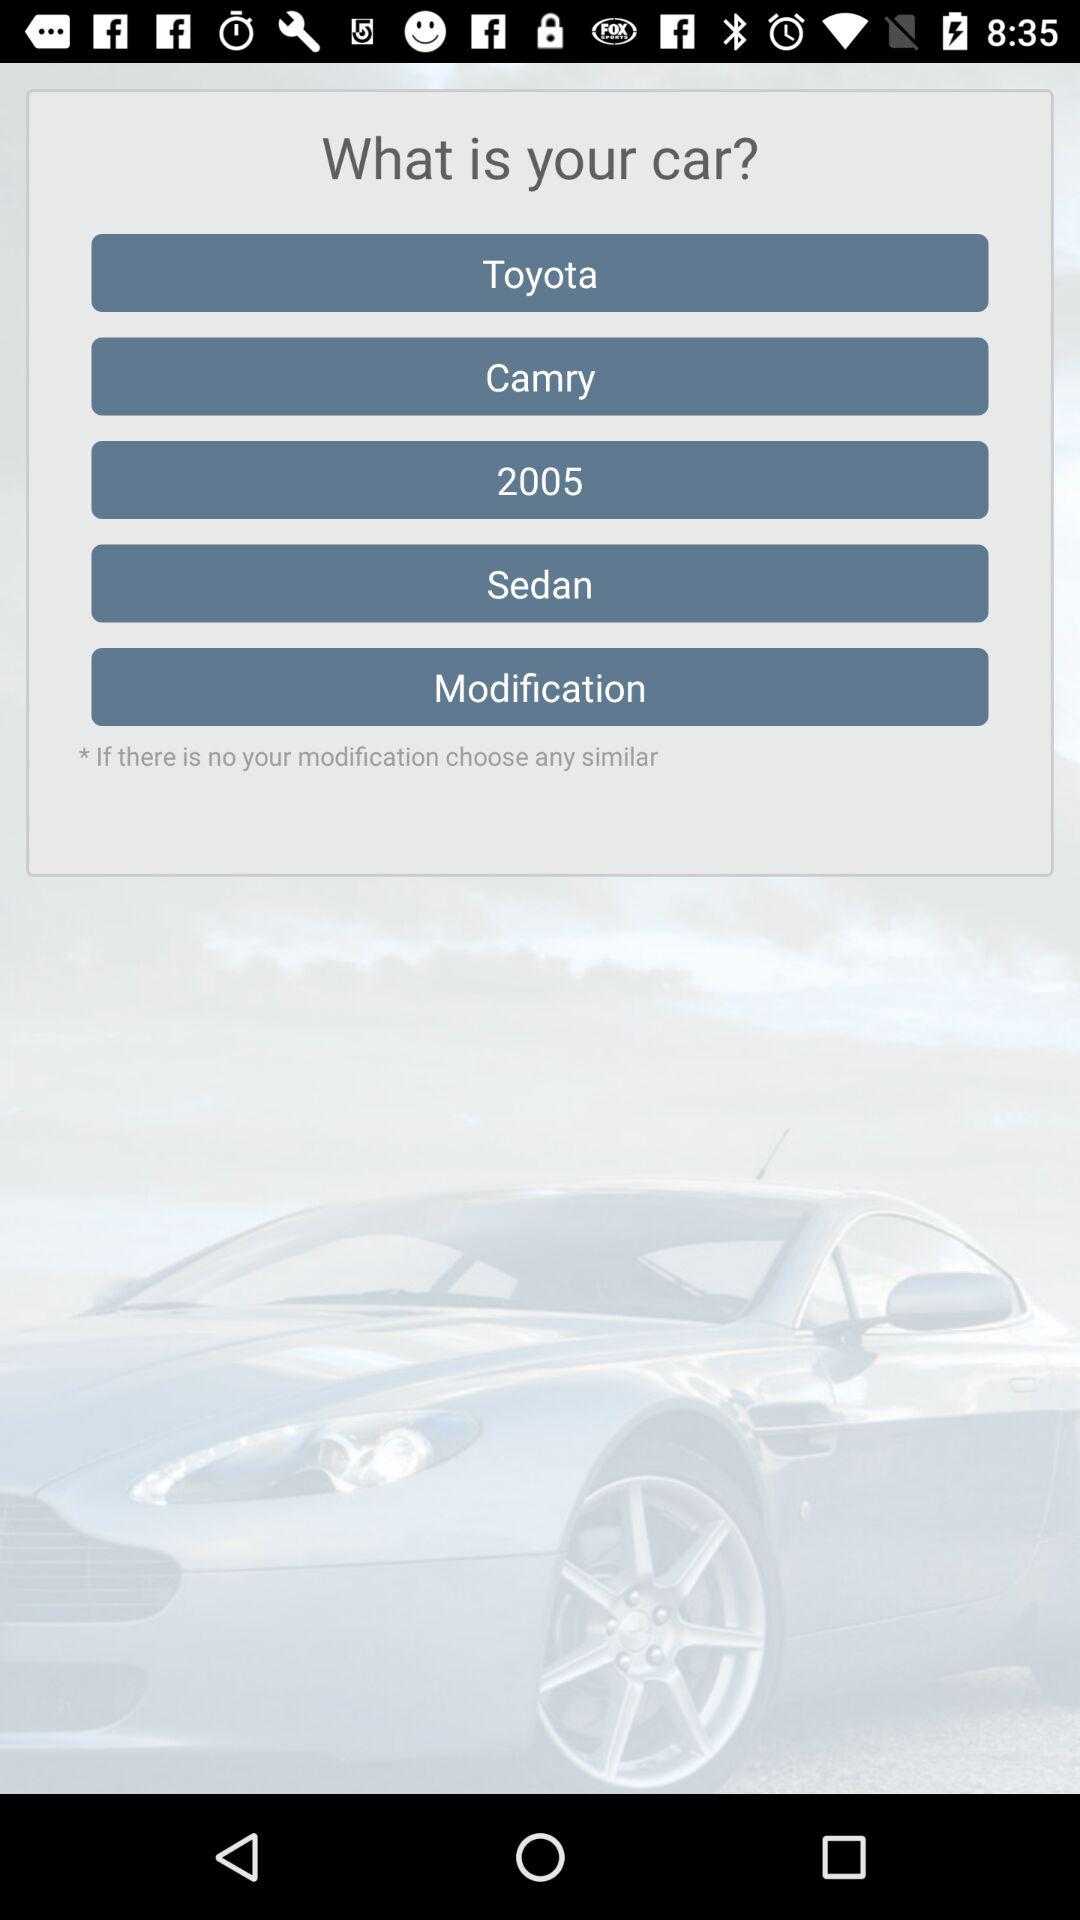What is the brand? The brand is Toyota. 